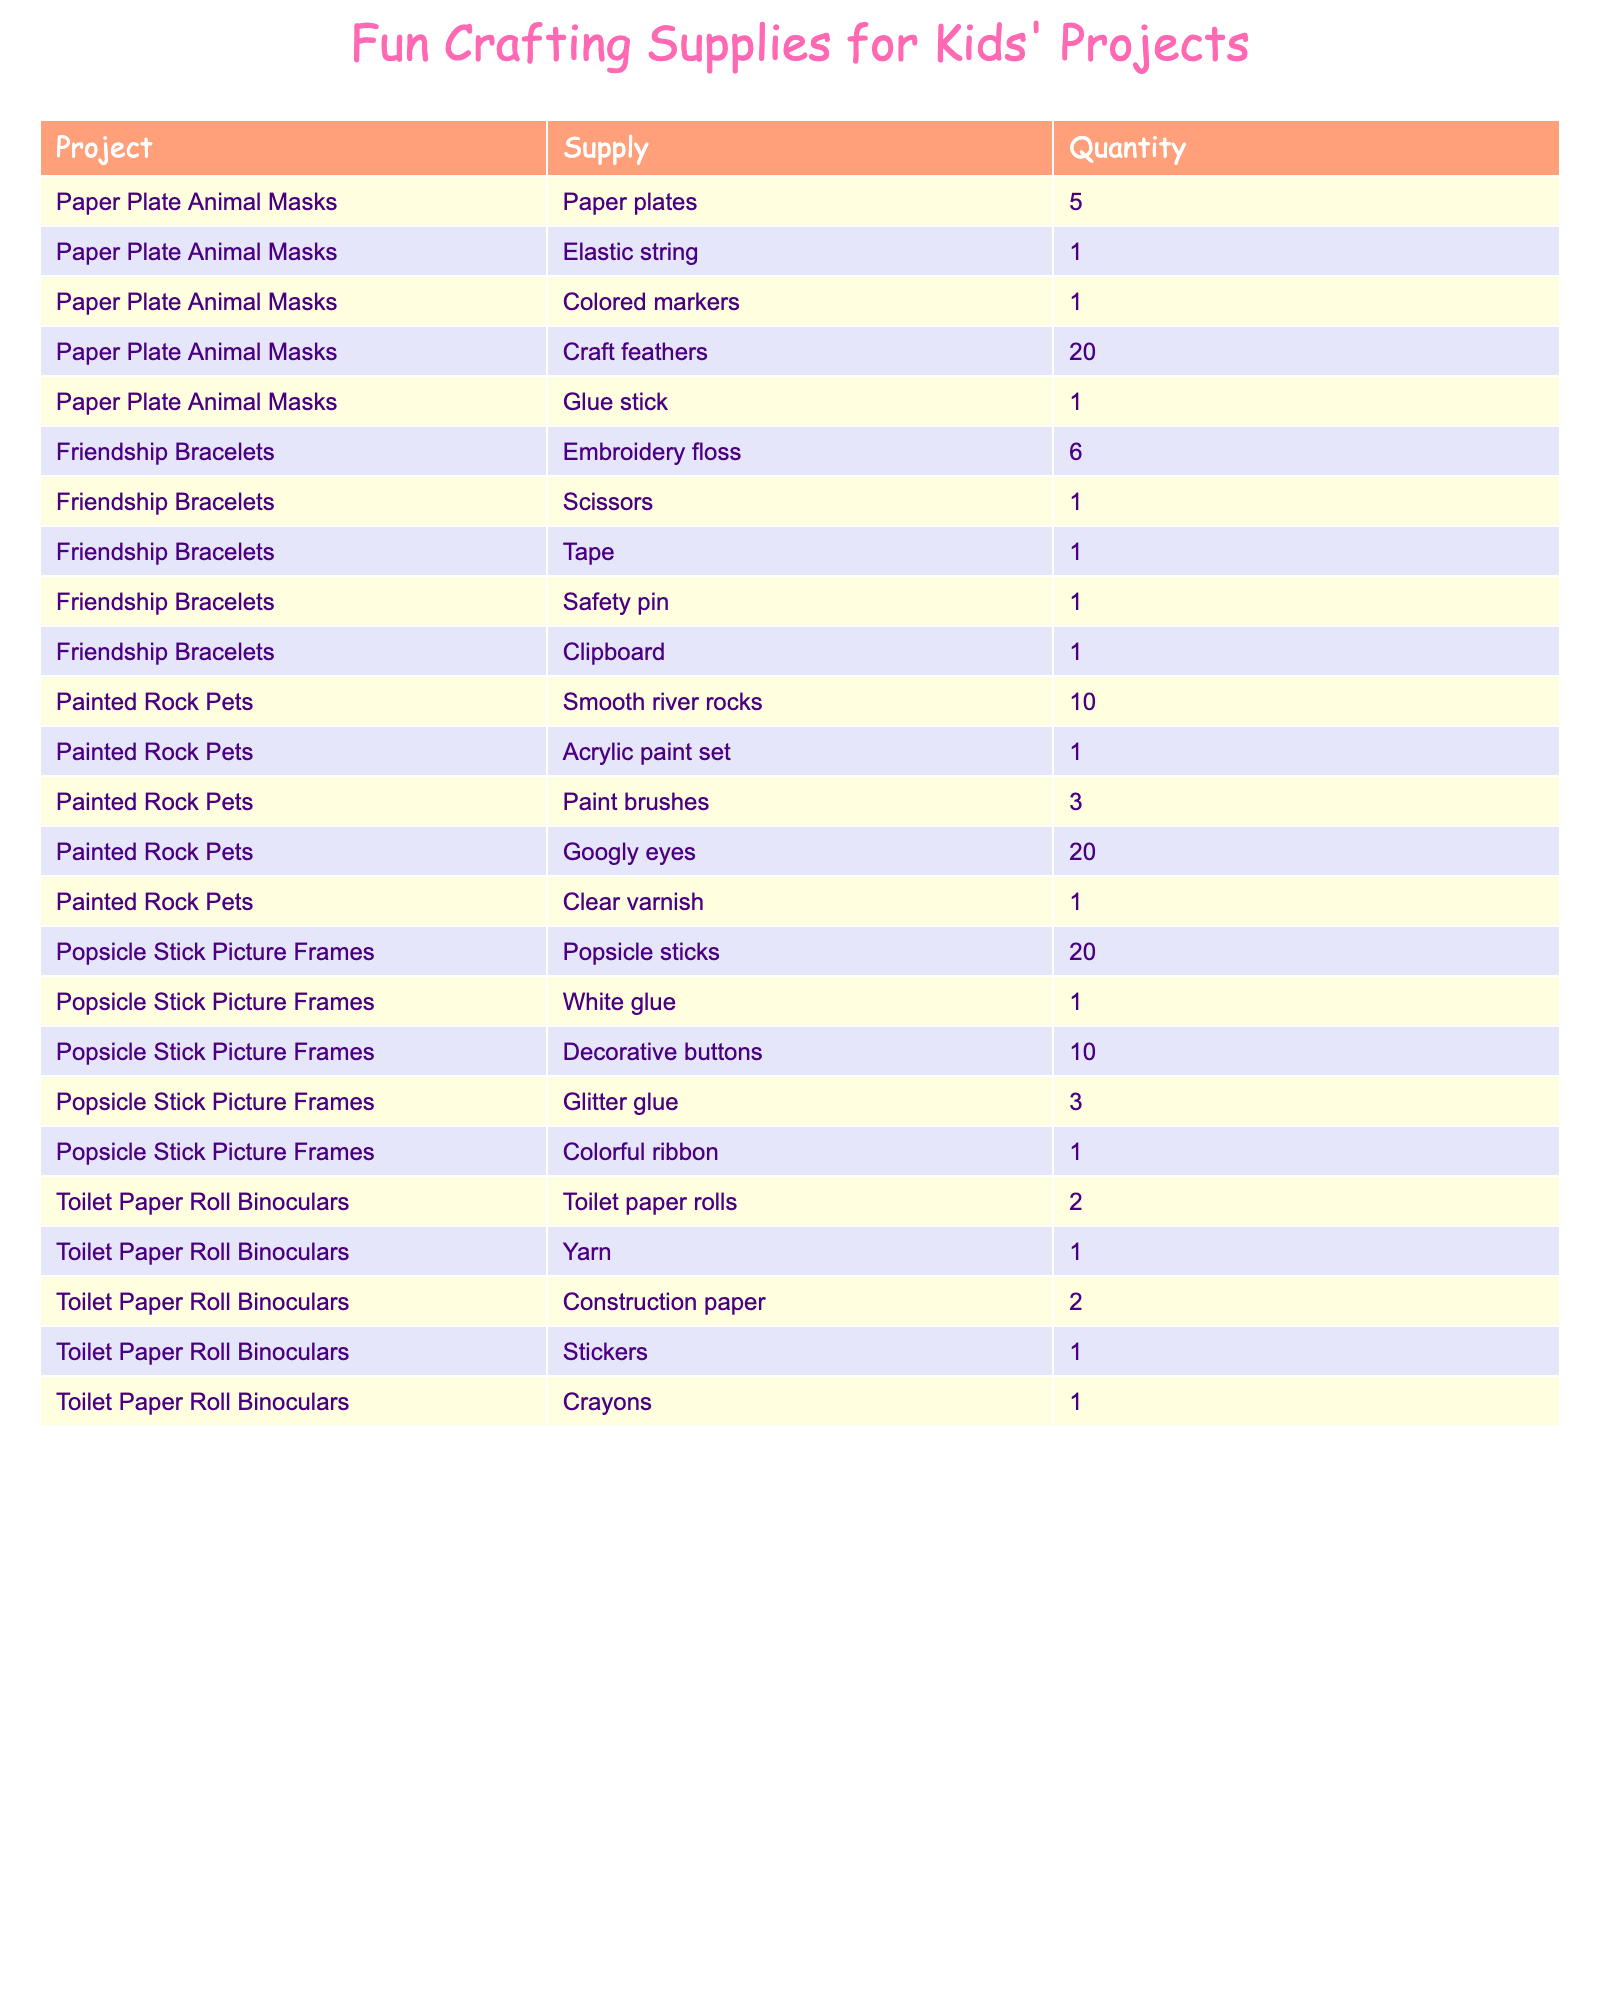What supplies are needed for making Painted Rock Pets? The table shows that the supplies needed for Painted Rock Pets are: Smooth river rocks (10), Acrylic paint set (1), Paint brushes (3), Googly eyes (20), and Clear varnish (1).
Answer: Smooth river rocks, Acrylic paint set, Paint brushes, Googly eyes, Clear varnish How many supplies are needed in total for Friendship Bracelets? There are 5 supplies listed for Friendship Bracelets: Embroidery floss (6), Scissors (1), Tape (1), Safety pin (1), and Clipboard (1). Adding these quantities gives: 6 + 1 + 1 + 1 + 1 = 10.
Answer: 10 Is there a supply that is needed for all projects listed? By checking the supplies listed for each project, none of the supplies appears in more than one project. Therefore, the answer is no.
Answer: No Which project requires the highest quantity of a single supply? Looking at the supplies, the highest quantity listed is 20 for Craft feathers in Paper Plate Animal Masks and Googly eyes in Painted Rock Pets. The answer should reflect both.
Answer: Craft feathers, Googly eyes What is the total number of unique supplies listed for all projects? The unique supplies across all projects can be counted as: Paper plates, Elastic string, Colored markers, Craft feathers, Glue stick, Embroidery floss, Scissors, Tape, Safety pin, Clipboard, Smooth river rocks, Acrylic paint set, Paint brushes, Googly eyes, Clear varnish, Popsicle sticks, White glue, Decorative buttons, Glitter glue, Colorful ribbon, Toilet paper rolls, Yarn, Construction paper, Stickers, and Crayons. This totals to 24 unique supplies.
Answer: 24 How many different types of projects use glue as a supply? From the table, we see that glue is used in two projects: Paper Plate Animal Masks (Glue stick) and Popsicle Stick Picture Frames (White glue). Hence, the answer is 2.
Answer: 2 Which project requires the least number of supplies? By analyzing each project, we find that Toilet Paper Roll Binoculars needs only 5 supplies: Toilet paper rolls (2), Yarn (1), Construction paper (2), Stickers (1), and Crayons (1). This is the least compared to others.
Answer: Toilet Paper Roll Binoculars What is the total quantity of Acrylic paint sets needed across projects? The table shows that only the Painted Rock Pets project requires 1 Acrylic paint set. Therefore, the total quantity for this supply is simply 1.
Answer: 1 How many supplies are needed for creating a Paper Plate Animal Mask compared to a Popsicle Stick Picture Frame? The Paper Plate Animal Masks require 5 supplies while the Popsicle Stick Picture Frames need 5 supplies as well. Thus, both require the same amount of supplies.
Answer: Same amount (5) 